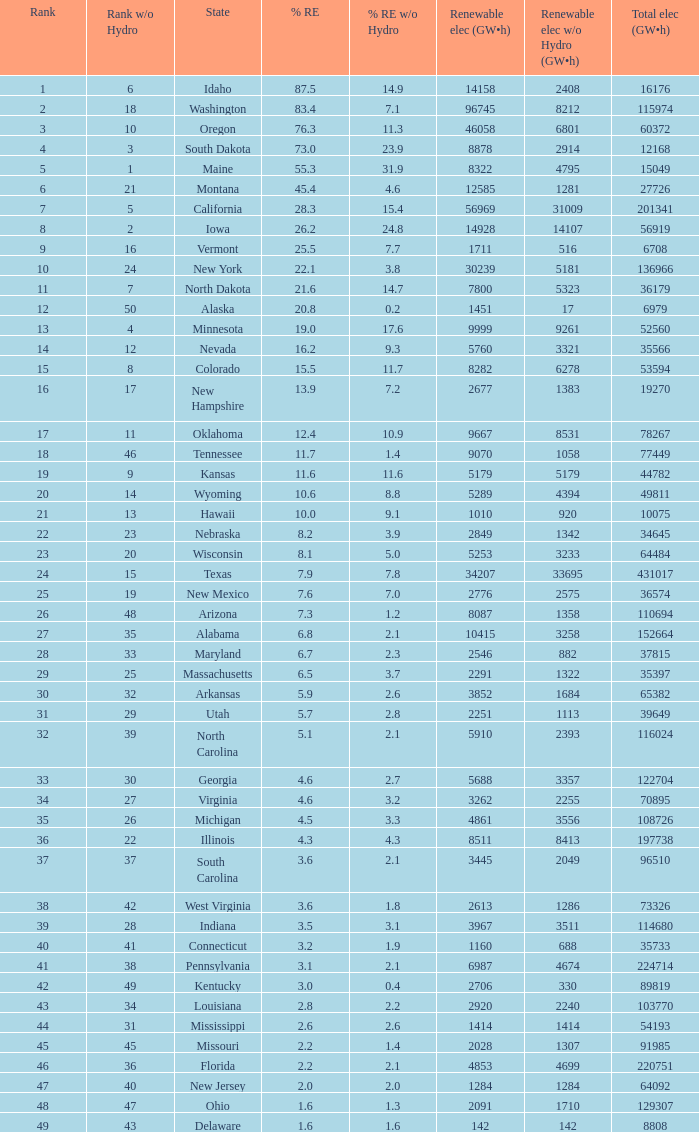What is the maximum renewable energy (gw×h) for the state of Delaware? 142.0. 